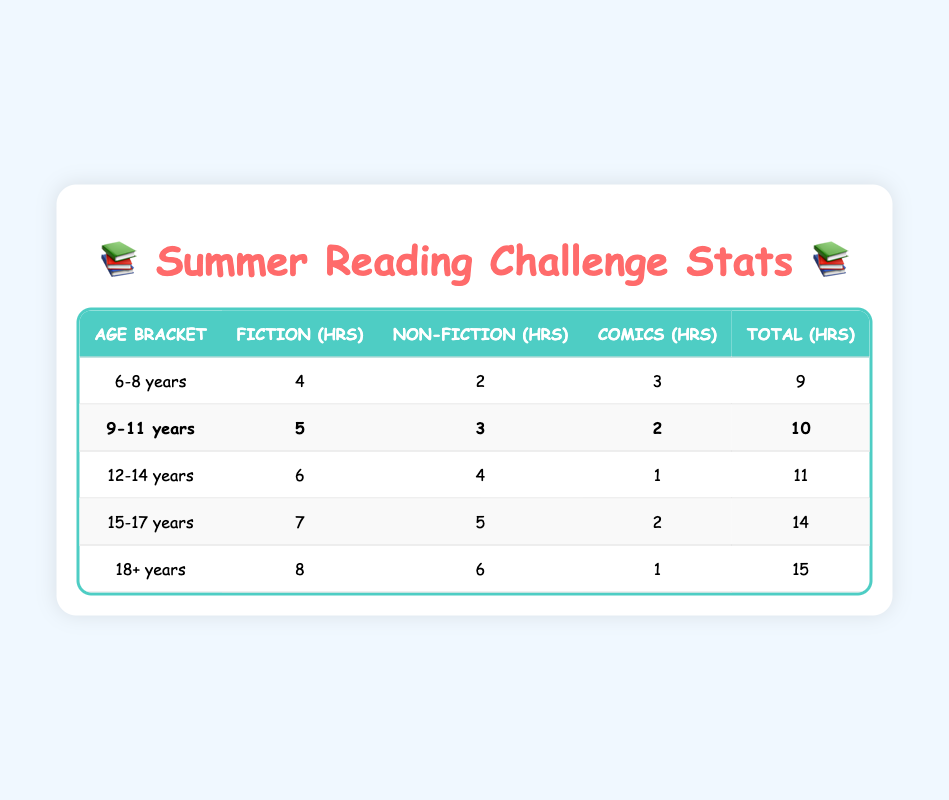What is the total average reading time for the 12-14 years age bracket? The total reading time for the 12-14 years age bracket is listed in the table as 11 hours.
Answer: 11 hours Which age bracket has the highest total reading time? The age bracket with the highest total reading time is the 18+ years category with a total of 15 hours.
Answer: 18+ years How many hours of fiction do 15-17 year olds read on average? The table shows that the average reading time for fiction in the 15-17 years age bracket is 7 hours.
Answer: 7 hours What is the difference in total reading time between the 9-11 years and 12-14 years age brackets? The total reading time for 9-11 years is 10 hours, and for 12-14 years, it is 11 hours. The difference is 11 - 10 = 1 hour.
Answer: 1 hour Is it true that 6-8 year olds read more fiction than comics? Yes, the table indicates that 6-8 year olds read 4 hours of fiction and 3 hours of comics, so they read more fiction.
Answer: Yes What is the total reading time for all age brackets combined? Summing the total reading times from each age bracket gives: 9 + 10 + 11 + 14 + 15 = 59 hours.
Answer: 59 hours What is the average comic reading time for the 9-11 years and 12-14 years age brackets combined? For 9-11 years, the comic reading time is 2 hours, and for 12-14 years, it is 1 hour. The average is (2 + 1) / 2 = 1.5 hours.
Answer: 1.5 hours Which age bracket has the lowest reading time for non-fiction? The age bracket with the lowest reading time for non-fiction is 6-8 years, with an average of 2 hours.
Answer: 6-8 years How much more total reading time do 15-17 year olds have compared to 6-8 year olds? The total reading time for 15-17 years is 14 hours and for 6-8 years is 9 hours. The difference is 14 - 9 = 5 hours.
Answer: 5 hours If you combined the reading times for all fiction across all age brackets, what would the total be? The total for fiction is 4 + 5 + 6 + 7 + 8 = 30 hours across all age brackets.
Answer: 30 hours 